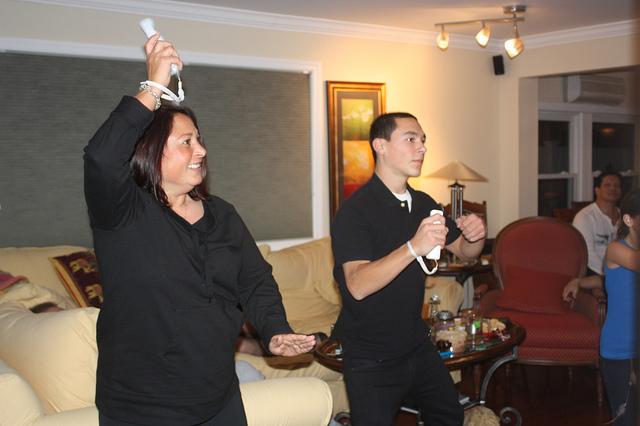What video game system are they playing?
Be succinct. Wii. Where is the lamp?
Quick response, please. Table. How many people are playing the game?
Answer briefly. 2. 